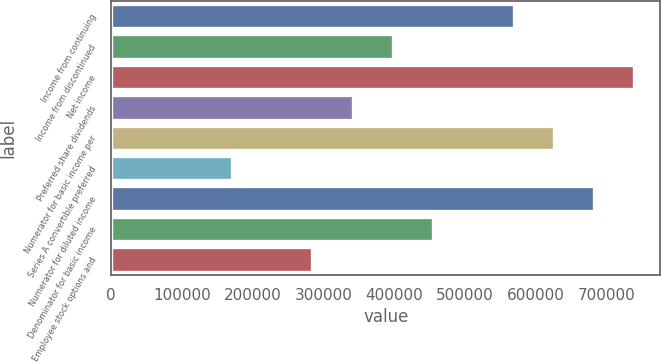<chart> <loc_0><loc_0><loc_500><loc_500><bar_chart><fcel>Income from continuing<fcel>Income from discontinued<fcel>Net income<fcel>Preferred share dividends<fcel>Numerator for basic income per<fcel>Series A convertible preferred<fcel>Numerator for diluted income<fcel>Denominator for basic income<fcel>Employee stock options and<nl><fcel>568906<fcel>398234<fcel>739578<fcel>341344<fcel>625797<fcel>170672<fcel>682687<fcel>455125<fcel>284453<nl></chart> 